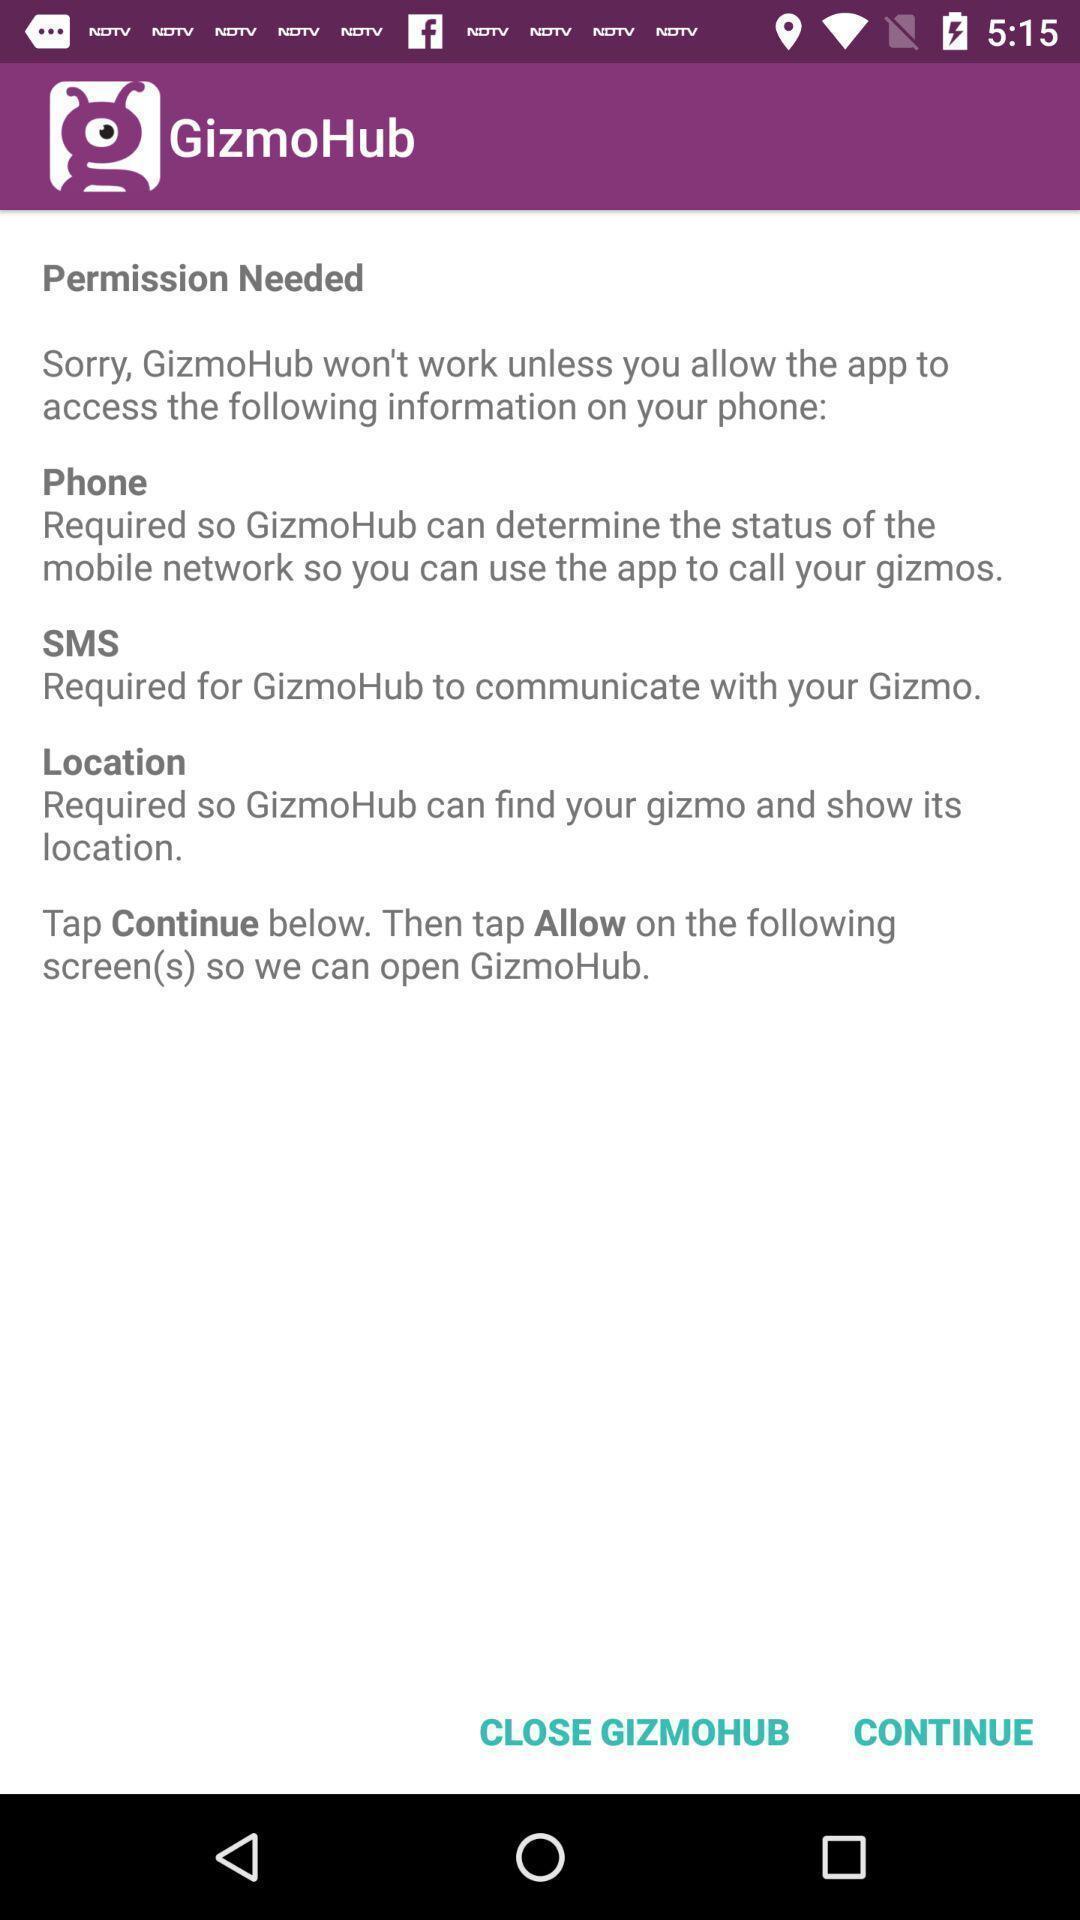Explain what's happening in this screen capture. Page displaying information about access required by the application. 